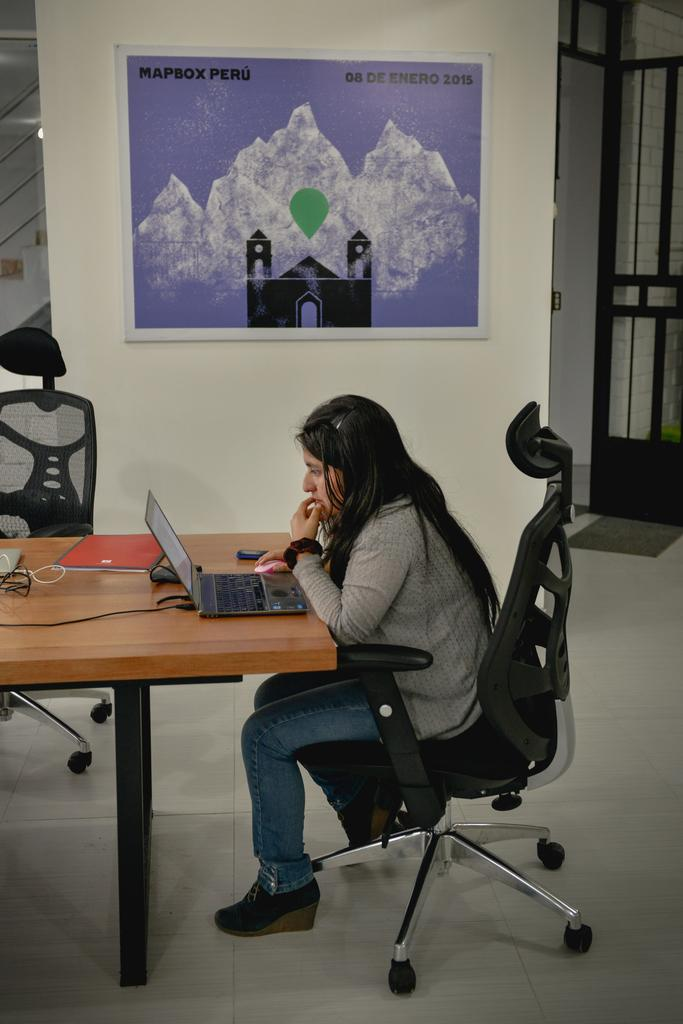What can be seen in the background of the image? There is a door and a board over a wall in the background of the image. What is the woman in the image doing? The woman is sitting on a chair in the image. Where is the woman located in relation to the table? The woman is in front of a table. What objects are on the table? There is a laptop and a pad on the table. On what surface does the scene take place? The scene takes place on a floor. How does the woman plan to join the selection process in the image? There is no indication of a selection process or any need for the woman to join one in the image. What type of amusement is present in the image? There is no amusement or entertainment-related object or activity depicted in the image. 